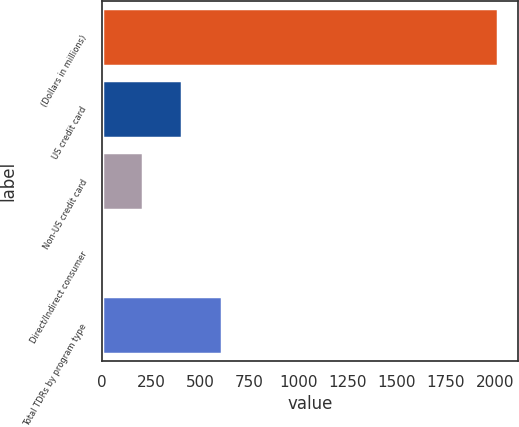<chart> <loc_0><loc_0><loc_500><loc_500><bar_chart><fcel>(Dollars in millions)<fcel>US credit card<fcel>Non-US credit card<fcel>Direct/Indirect consumer<fcel>Total TDRs by program type<nl><fcel>2015<fcel>408.6<fcel>207.8<fcel>7<fcel>609.4<nl></chart> 